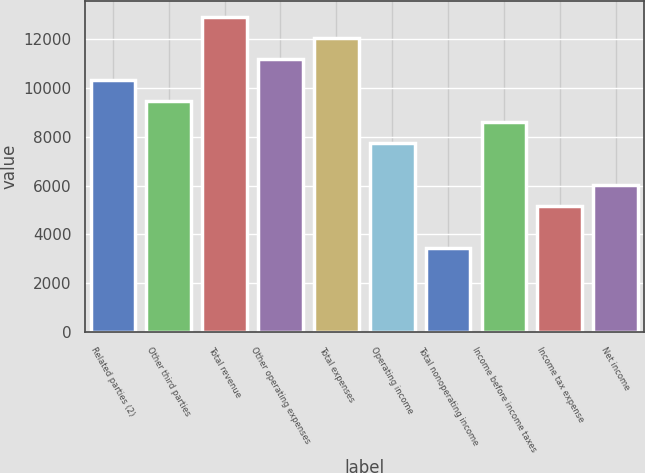Convert chart. <chart><loc_0><loc_0><loc_500><loc_500><bar_chart><fcel>Related parties (2)<fcel>Other third parties<fcel>Total revenue<fcel>Other operating expenses<fcel>Total expenses<fcel>Operating income<fcel>Total nonoperating income<fcel>Income before income taxes<fcel>Income tax expense<fcel>Net income<nl><fcel>10333.6<fcel>9472.8<fcel>12916<fcel>11194.4<fcel>12055.2<fcel>7751.2<fcel>3447.2<fcel>8612<fcel>5168.8<fcel>6029.6<nl></chart> 